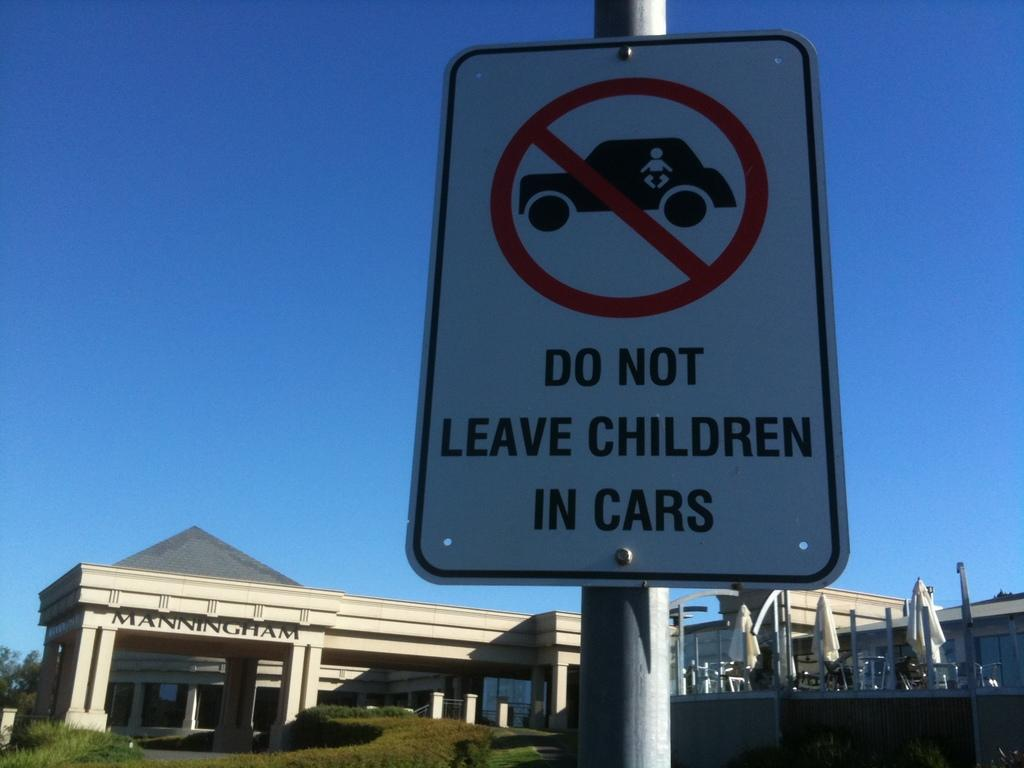<image>
Create a compact narrative representing the image presented. A sign tells motorists to not leave children in cars. 